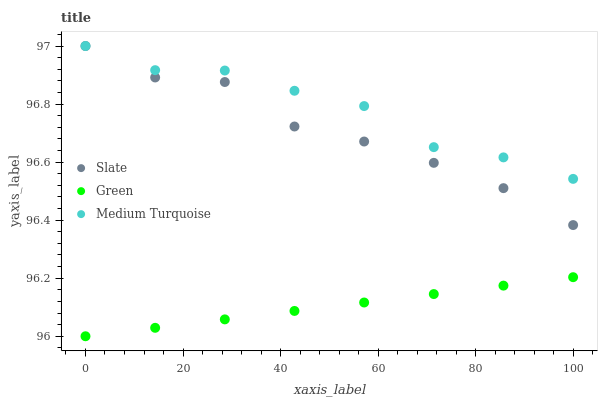Does Green have the minimum area under the curve?
Answer yes or no. Yes. Does Medium Turquoise have the maximum area under the curve?
Answer yes or no. Yes. Does Medium Turquoise have the minimum area under the curve?
Answer yes or no. No. Does Green have the maximum area under the curve?
Answer yes or no. No. Is Green the smoothest?
Answer yes or no. Yes. Is Slate the roughest?
Answer yes or no. Yes. Is Medium Turquoise the smoothest?
Answer yes or no. No. Is Medium Turquoise the roughest?
Answer yes or no. No. Does Green have the lowest value?
Answer yes or no. Yes. Does Medium Turquoise have the lowest value?
Answer yes or no. No. Does Medium Turquoise have the highest value?
Answer yes or no. Yes. Does Green have the highest value?
Answer yes or no. No. Is Green less than Medium Turquoise?
Answer yes or no. Yes. Is Medium Turquoise greater than Green?
Answer yes or no. Yes. Does Medium Turquoise intersect Slate?
Answer yes or no. Yes. Is Medium Turquoise less than Slate?
Answer yes or no. No. Is Medium Turquoise greater than Slate?
Answer yes or no. No. Does Green intersect Medium Turquoise?
Answer yes or no. No. 